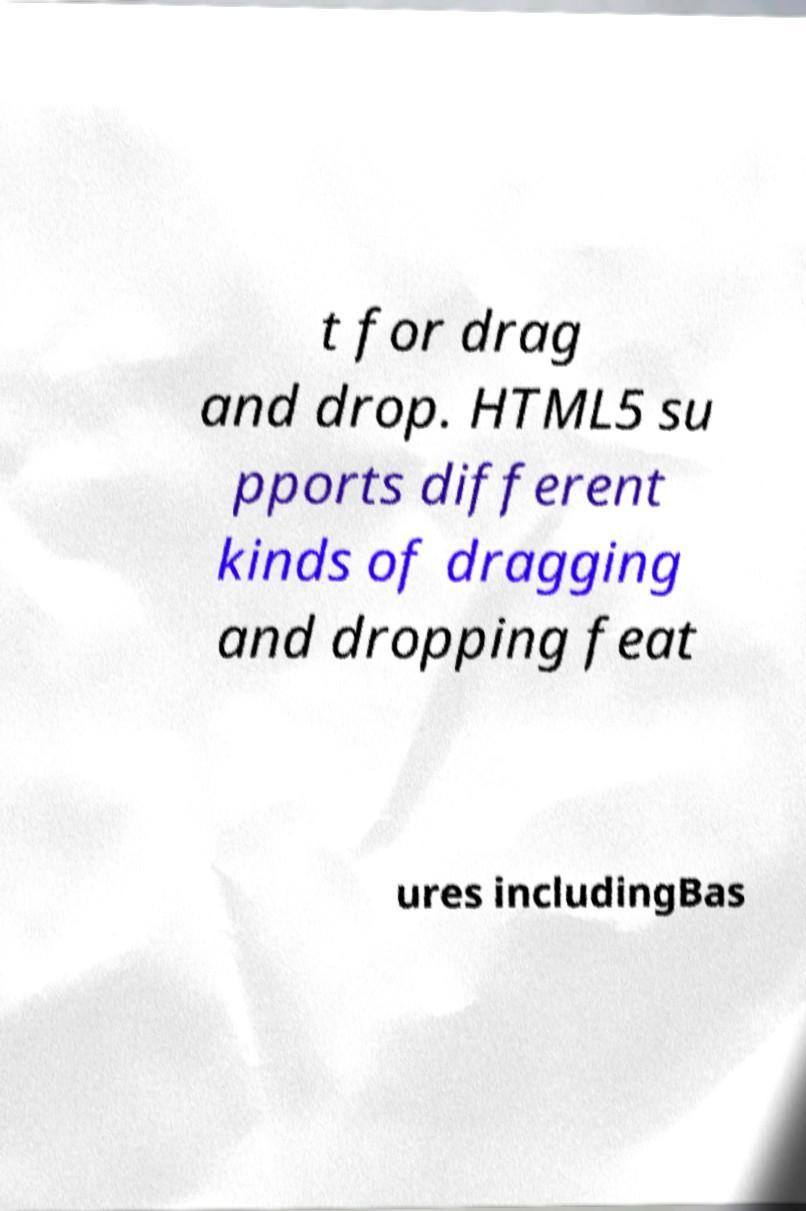Could you assist in decoding the text presented in this image and type it out clearly? t for drag and drop. HTML5 su pports different kinds of dragging and dropping feat ures includingBas 